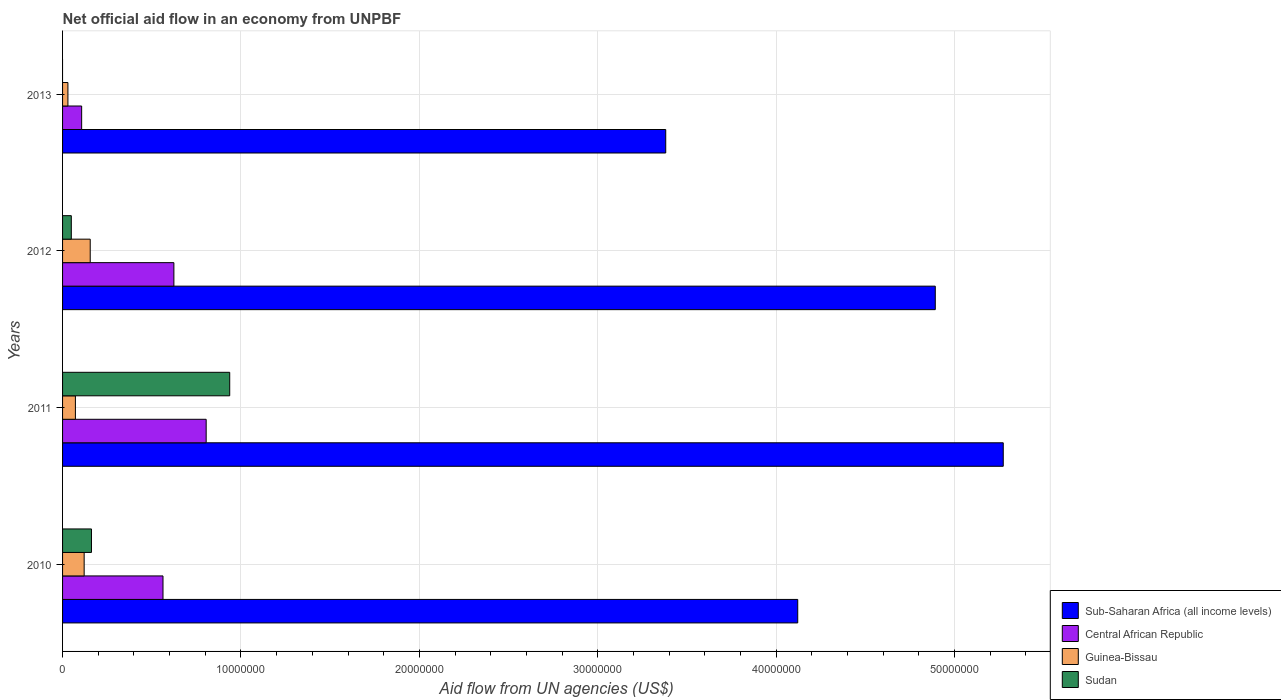How many different coloured bars are there?
Keep it short and to the point. 4. Are the number of bars on each tick of the Y-axis equal?
Provide a short and direct response. No. How many bars are there on the 1st tick from the top?
Offer a very short reply. 3. What is the label of the 4th group of bars from the top?
Offer a very short reply. 2010. In how many cases, is the number of bars for a given year not equal to the number of legend labels?
Provide a succinct answer. 1. What is the net official aid flow in Guinea-Bissau in 2013?
Provide a short and direct response. 3.00e+05. Across all years, what is the maximum net official aid flow in Central African Republic?
Provide a succinct answer. 8.05e+06. Across all years, what is the minimum net official aid flow in Sudan?
Give a very brief answer. 0. In which year was the net official aid flow in Sudan maximum?
Offer a very short reply. 2011. What is the total net official aid flow in Central African Republic in the graph?
Provide a short and direct response. 2.10e+07. What is the difference between the net official aid flow in Guinea-Bissau in 2011 and that in 2012?
Provide a succinct answer. -8.30e+05. What is the difference between the net official aid flow in Central African Republic in 2010 and the net official aid flow in Guinea-Bissau in 2012?
Provide a short and direct response. 4.08e+06. What is the average net official aid flow in Sudan per year?
Give a very brief answer. 2.87e+06. In the year 2011, what is the difference between the net official aid flow in Sub-Saharan Africa (all income levels) and net official aid flow in Sudan?
Your response must be concise. 4.34e+07. What is the ratio of the net official aid flow in Sub-Saharan Africa (all income levels) in 2010 to that in 2011?
Give a very brief answer. 0.78. Is the net official aid flow in Central African Republic in 2010 less than that in 2013?
Your response must be concise. No. Is the difference between the net official aid flow in Sub-Saharan Africa (all income levels) in 2010 and 2011 greater than the difference between the net official aid flow in Sudan in 2010 and 2011?
Give a very brief answer. No. What is the difference between the highest and the lowest net official aid flow in Central African Republic?
Make the answer very short. 6.98e+06. In how many years, is the net official aid flow in Sub-Saharan Africa (all income levels) greater than the average net official aid flow in Sub-Saharan Africa (all income levels) taken over all years?
Give a very brief answer. 2. Is the sum of the net official aid flow in Sub-Saharan Africa (all income levels) in 2011 and 2012 greater than the maximum net official aid flow in Guinea-Bissau across all years?
Offer a terse response. Yes. How many bars are there?
Ensure brevity in your answer.  15. Are all the bars in the graph horizontal?
Your answer should be very brief. Yes. How many years are there in the graph?
Provide a succinct answer. 4. What is the title of the graph?
Offer a very short reply. Net official aid flow in an economy from UNPBF. Does "Sint Maarten (Dutch part)" appear as one of the legend labels in the graph?
Keep it short and to the point. No. What is the label or title of the X-axis?
Keep it short and to the point. Aid flow from UN agencies (US$). What is the label or title of the Y-axis?
Your answer should be very brief. Years. What is the Aid flow from UN agencies (US$) in Sub-Saharan Africa (all income levels) in 2010?
Ensure brevity in your answer.  4.12e+07. What is the Aid flow from UN agencies (US$) of Central African Republic in 2010?
Your response must be concise. 5.63e+06. What is the Aid flow from UN agencies (US$) in Guinea-Bissau in 2010?
Your answer should be compact. 1.21e+06. What is the Aid flow from UN agencies (US$) of Sudan in 2010?
Your answer should be compact. 1.62e+06. What is the Aid flow from UN agencies (US$) of Sub-Saharan Africa (all income levels) in 2011?
Make the answer very short. 5.27e+07. What is the Aid flow from UN agencies (US$) in Central African Republic in 2011?
Your answer should be compact. 8.05e+06. What is the Aid flow from UN agencies (US$) of Guinea-Bissau in 2011?
Ensure brevity in your answer.  7.20e+05. What is the Aid flow from UN agencies (US$) of Sudan in 2011?
Keep it short and to the point. 9.37e+06. What is the Aid flow from UN agencies (US$) of Sub-Saharan Africa (all income levels) in 2012?
Your response must be concise. 4.89e+07. What is the Aid flow from UN agencies (US$) in Central African Republic in 2012?
Your response must be concise. 6.24e+06. What is the Aid flow from UN agencies (US$) of Guinea-Bissau in 2012?
Your answer should be compact. 1.55e+06. What is the Aid flow from UN agencies (US$) in Sub-Saharan Africa (all income levels) in 2013?
Offer a very short reply. 3.38e+07. What is the Aid flow from UN agencies (US$) in Central African Republic in 2013?
Provide a short and direct response. 1.07e+06. What is the Aid flow from UN agencies (US$) in Sudan in 2013?
Offer a very short reply. 0. Across all years, what is the maximum Aid flow from UN agencies (US$) of Sub-Saharan Africa (all income levels)?
Ensure brevity in your answer.  5.27e+07. Across all years, what is the maximum Aid flow from UN agencies (US$) of Central African Republic?
Give a very brief answer. 8.05e+06. Across all years, what is the maximum Aid flow from UN agencies (US$) in Guinea-Bissau?
Keep it short and to the point. 1.55e+06. Across all years, what is the maximum Aid flow from UN agencies (US$) in Sudan?
Provide a succinct answer. 9.37e+06. Across all years, what is the minimum Aid flow from UN agencies (US$) in Sub-Saharan Africa (all income levels)?
Keep it short and to the point. 3.38e+07. Across all years, what is the minimum Aid flow from UN agencies (US$) in Central African Republic?
Your answer should be very brief. 1.07e+06. Across all years, what is the minimum Aid flow from UN agencies (US$) in Guinea-Bissau?
Your answer should be compact. 3.00e+05. Across all years, what is the minimum Aid flow from UN agencies (US$) of Sudan?
Provide a succinct answer. 0. What is the total Aid flow from UN agencies (US$) of Sub-Saharan Africa (all income levels) in the graph?
Offer a very short reply. 1.77e+08. What is the total Aid flow from UN agencies (US$) of Central African Republic in the graph?
Your answer should be compact. 2.10e+07. What is the total Aid flow from UN agencies (US$) in Guinea-Bissau in the graph?
Make the answer very short. 3.78e+06. What is the total Aid flow from UN agencies (US$) in Sudan in the graph?
Keep it short and to the point. 1.15e+07. What is the difference between the Aid flow from UN agencies (US$) in Sub-Saharan Africa (all income levels) in 2010 and that in 2011?
Provide a succinct answer. -1.15e+07. What is the difference between the Aid flow from UN agencies (US$) in Central African Republic in 2010 and that in 2011?
Make the answer very short. -2.42e+06. What is the difference between the Aid flow from UN agencies (US$) of Sudan in 2010 and that in 2011?
Your response must be concise. -7.75e+06. What is the difference between the Aid flow from UN agencies (US$) in Sub-Saharan Africa (all income levels) in 2010 and that in 2012?
Provide a succinct answer. -7.71e+06. What is the difference between the Aid flow from UN agencies (US$) of Central African Republic in 2010 and that in 2012?
Your response must be concise. -6.10e+05. What is the difference between the Aid flow from UN agencies (US$) in Sudan in 2010 and that in 2012?
Provide a short and direct response. 1.13e+06. What is the difference between the Aid flow from UN agencies (US$) in Sub-Saharan Africa (all income levels) in 2010 and that in 2013?
Your response must be concise. 7.40e+06. What is the difference between the Aid flow from UN agencies (US$) of Central African Republic in 2010 and that in 2013?
Keep it short and to the point. 4.56e+06. What is the difference between the Aid flow from UN agencies (US$) in Guinea-Bissau in 2010 and that in 2013?
Offer a very short reply. 9.10e+05. What is the difference between the Aid flow from UN agencies (US$) of Sub-Saharan Africa (all income levels) in 2011 and that in 2012?
Ensure brevity in your answer.  3.81e+06. What is the difference between the Aid flow from UN agencies (US$) of Central African Republic in 2011 and that in 2012?
Provide a succinct answer. 1.81e+06. What is the difference between the Aid flow from UN agencies (US$) of Guinea-Bissau in 2011 and that in 2012?
Offer a terse response. -8.30e+05. What is the difference between the Aid flow from UN agencies (US$) of Sudan in 2011 and that in 2012?
Give a very brief answer. 8.88e+06. What is the difference between the Aid flow from UN agencies (US$) in Sub-Saharan Africa (all income levels) in 2011 and that in 2013?
Your answer should be compact. 1.89e+07. What is the difference between the Aid flow from UN agencies (US$) in Central African Republic in 2011 and that in 2013?
Your answer should be compact. 6.98e+06. What is the difference between the Aid flow from UN agencies (US$) in Sub-Saharan Africa (all income levels) in 2012 and that in 2013?
Offer a terse response. 1.51e+07. What is the difference between the Aid flow from UN agencies (US$) of Central African Republic in 2012 and that in 2013?
Provide a succinct answer. 5.17e+06. What is the difference between the Aid flow from UN agencies (US$) in Guinea-Bissau in 2012 and that in 2013?
Offer a very short reply. 1.25e+06. What is the difference between the Aid flow from UN agencies (US$) of Sub-Saharan Africa (all income levels) in 2010 and the Aid flow from UN agencies (US$) of Central African Republic in 2011?
Offer a terse response. 3.32e+07. What is the difference between the Aid flow from UN agencies (US$) of Sub-Saharan Africa (all income levels) in 2010 and the Aid flow from UN agencies (US$) of Guinea-Bissau in 2011?
Provide a short and direct response. 4.05e+07. What is the difference between the Aid flow from UN agencies (US$) in Sub-Saharan Africa (all income levels) in 2010 and the Aid flow from UN agencies (US$) in Sudan in 2011?
Provide a short and direct response. 3.18e+07. What is the difference between the Aid flow from UN agencies (US$) in Central African Republic in 2010 and the Aid flow from UN agencies (US$) in Guinea-Bissau in 2011?
Offer a very short reply. 4.91e+06. What is the difference between the Aid flow from UN agencies (US$) in Central African Republic in 2010 and the Aid flow from UN agencies (US$) in Sudan in 2011?
Offer a terse response. -3.74e+06. What is the difference between the Aid flow from UN agencies (US$) in Guinea-Bissau in 2010 and the Aid flow from UN agencies (US$) in Sudan in 2011?
Your response must be concise. -8.16e+06. What is the difference between the Aid flow from UN agencies (US$) of Sub-Saharan Africa (all income levels) in 2010 and the Aid flow from UN agencies (US$) of Central African Republic in 2012?
Keep it short and to the point. 3.50e+07. What is the difference between the Aid flow from UN agencies (US$) of Sub-Saharan Africa (all income levels) in 2010 and the Aid flow from UN agencies (US$) of Guinea-Bissau in 2012?
Offer a very short reply. 3.97e+07. What is the difference between the Aid flow from UN agencies (US$) of Sub-Saharan Africa (all income levels) in 2010 and the Aid flow from UN agencies (US$) of Sudan in 2012?
Offer a terse response. 4.07e+07. What is the difference between the Aid flow from UN agencies (US$) in Central African Republic in 2010 and the Aid flow from UN agencies (US$) in Guinea-Bissau in 2012?
Give a very brief answer. 4.08e+06. What is the difference between the Aid flow from UN agencies (US$) in Central African Republic in 2010 and the Aid flow from UN agencies (US$) in Sudan in 2012?
Keep it short and to the point. 5.14e+06. What is the difference between the Aid flow from UN agencies (US$) in Guinea-Bissau in 2010 and the Aid flow from UN agencies (US$) in Sudan in 2012?
Make the answer very short. 7.20e+05. What is the difference between the Aid flow from UN agencies (US$) in Sub-Saharan Africa (all income levels) in 2010 and the Aid flow from UN agencies (US$) in Central African Republic in 2013?
Make the answer very short. 4.01e+07. What is the difference between the Aid flow from UN agencies (US$) of Sub-Saharan Africa (all income levels) in 2010 and the Aid flow from UN agencies (US$) of Guinea-Bissau in 2013?
Offer a terse response. 4.09e+07. What is the difference between the Aid flow from UN agencies (US$) in Central African Republic in 2010 and the Aid flow from UN agencies (US$) in Guinea-Bissau in 2013?
Your answer should be compact. 5.33e+06. What is the difference between the Aid flow from UN agencies (US$) of Sub-Saharan Africa (all income levels) in 2011 and the Aid flow from UN agencies (US$) of Central African Republic in 2012?
Offer a very short reply. 4.65e+07. What is the difference between the Aid flow from UN agencies (US$) in Sub-Saharan Africa (all income levels) in 2011 and the Aid flow from UN agencies (US$) in Guinea-Bissau in 2012?
Make the answer very short. 5.12e+07. What is the difference between the Aid flow from UN agencies (US$) in Sub-Saharan Africa (all income levels) in 2011 and the Aid flow from UN agencies (US$) in Sudan in 2012?
Give a very brief answer. 5.22e+07. What is the difference between the Aid flow from UN agencies (US$) of Central African Republic in 2011 and the Aid flow from UN agencies (US$) of Guinea-Bissau in 2012?
Give a very brief answer. 6.50e+06. What is the difference between the Aid flow from UN agencies (US$) of Central African Republic in 2011 and the Aid flow from UN agencies (US$) of Sudan in 2012?
Provide a succinct answer. 7.56e+06. What is the difference between the Aid flow from UN agencies (US$) in Sub-Saharan Africa (all income levels) in 2011 and the Aid flow from UN agencies (US$) in Central African Republic in 2013?
Your answer should be compact. 5.17e+07. What is the difference between the Aid flow from UN agencies (US$) in Sub-Saharan Africa (all income levels) in 2011 and the Aid flow from UN agencies (US$) in Guinea-Bissau in 2013?
Offer a very short reply. 5.24e+07. What is the difference between the Aid flow from UN agencies (US$) of Central African Republic in 2011 and the Aid flow from UN agencies (US$) of Guinea-Bissau in 2013?
Provide a succinct answer. 7.75e+06. What is the difference between the Aid flow from UN agencies (US$) of Sub-Saharan Africa (all income levels) in 2012 and the Aid flow from UN agencies (US$) of Central African Republic in 2013?
Ensure brevity in your answer.  4.78e+07. What is the difference between the Aid flow from UN agencies (US$) of Sub-Saharan Africa (all income levels) in 2012 and the Aid flow from UN agencies (US$) of Guinea-Bissau in 2013?
Ensure brevity in your answer.  4.86e+07. What is the difference between the Aid flow from UN agencies (US$) of Central African Republic in 2012 and the Aid flow from UN agencies (US$) of Guinea-Bissau in 2013?
Keep it short and to the point. 5.94e+06. What is the average Aid flow from UN agencies (US$) of Sub-Saharan Africa (all income levels) per year?
Your response must be concise. 4.42e+07. What is the average Aid flow from UN agencies (US$) in Central African Republic per year?
Make the answer very short. 5.25e+06. What is the average Aid flow from UN agencies (US$) in Guinea-Bissau per year?
Provide a short and direct response. 9.45e+05. What is the average Aid flow from UN agencies (US$) in Sudan per year?
Your response must be concise. 2.87e+06. In the year 2010, what is the difference between the Aid flow from UN agencies (US$) of Sub-Saharan Africa (all income levels) and Aid flow from UN agencies (US$) of Central African Republic?
Provide a short and direct response. 3.56e+07. In the year 2010, what is the difference between the Aid flow from UN agencies (US$) in Sub-Saharan Africa (all income levels) and Aid flow from UN agencies (US$) in Guinea-Bissau?
Keep it short and to the point. 4.00e+07. In the year 2010, what is the difference between the Aid flow from UN agencies (US$) of Sub-Saharan Africa (all income levels) and Aid flow from UN agencies (US$) of Sudan?
Give a very brief answer. 3.96e+07. In the year 2010, what is the difference between the Aid flow from UN agencies (US$) in Central African Republic and Aid flow from UN agencies (US$) in Guinea-Bissau?
Provide a short and direct response. 4.42e+06. In the year 2010, what is the difference between the Aid flow from UN agencies (US$) of Central African Republic and Aid flow from UN agencies (US$) of Sudan?
Offer a very short reply. 4.01e+06. In the year 2010, what is the difference between the Aid flow from UN agencies (US$) of Guinea-Bissau and Aid flow from UN agencies (US$) of Sudan?
Offer a terse response. -4.10e+05. In the year 2011, what is the difference between the Aid flow from UN agencies (US$) of Sub-Saharan Africa (all income levels) and Aid flow from UN agencies (US$) of Central African Republic?
Provide a short and direct response. 4.47e+07. In the year 2011, what is the difference between the Aid flow from UN agencies (US$) of Sub-Saharan Africa (all income levels) and Aid flow from UN agencies (US$) of Guinea-Bissau?
Give a very brief answer. 5.20e+07. In the year 2011, what is the difference between the Aid flow from UN agencies (US$) in Sub-Saharan Africa (all income levels) and Aid flow from UN agencies (US$) in Sudan?
Your answer should be compact. 4.34e+07. In the year 2011, what is the difference between the Aid flow from UN agencies (US$) of Central African Republic and Aid flow from UN agencies (US$) of Guinea-Bissau?
Your answer should be compact. 7.33e+06. In the year 2011, what is the difference between the Aid flow from UN agencies (US$) of Central African Republic and Aid flow from UN agencies (US$) of Sudan?
Keep it short and to the point. -1.32e+06. In the year 2011, what is the difference between the Aid flow from UN agencies (US$) in Guinea-Bissau and Aid flow from UN agencies (US$) in Sudan?
Make the answer very short. -8.65e+06. In the year 2012, what is the difference between the Aid flow from UN agencies (US$) of Sub-Saharan Africa (all income levels) and Aid flow from UN agencies (US$) of Central African Republic?
Ensure brevity in your answer.  4.27e+07. In the year 2012, what is the difference between the Aid flow from UN agencies (US$) of Sub-Saharan Africa (all income levels) and Aid flow from UN agencies (US$) of Guinea-Bissau?
Make the answer very short. 4.74e+07. In the year 2012, what is the difference between the Aid flow from UN agencies (US$) of Sub-Saharan Africa (all income levels) and Aid flow from UN agencies (US$) of Sudan?
Provide a succinct answer. 4.84e+07. In the year 2012, what is the difference between the Aid flow from UN agencies (US$) of Central African Republic and Aid flow from UN agencies (US$) of Guinea-Bissau?
Offer a terse response. 4.69e+06. In the year 2012, what is the difference between the Aid flow from UN agencies (US$) in Central African Republic and Aid flow from UN agencies (US$) in Sudan?
Make the answer very short. 5.75e+06. In the year 2012, what is the difference between the Aid flow from UN agencies (US$) of Guinea-Bissau and Aid flow from UN agencies (US$) of Sudan?
Give a very brief answer. 1.06e+06. In the year 2013, what is the difference between the Aid flow from UN agencies (US$) of Sub-Saharan Africa (all income levels) and Aid flow from UN agencies (US$) of Central African Republic?
Provide a short and direct response. 3.27e+07. In the year 2013, what is the difference between the Aid flow from UN agencies (US$) of Sub-Saharan Africa (all income levels) and Aid flow from UN agencies (US$) of Guinea-Bissau?
Give a very brief answer. 3.35e+07. In the year 2013, what is the difference between the Aid flow from UN agencies (US$) of Central African Republic and Aid flow from UN agencies (US$) of Guinea-Bissau?
Your answer should be compact. 7.70e+05. What is the ratio of the Aid flow from UN agencies (US$) of Sub-Saharan Africa (all income levels) in 2010 to that in 2011?
Give a very brief answer. 0.78. What is the ratio of the Aid flow from UN agencies (US$) of Central African Republic in 2010 to that in 2011?
Your response must be concise. 0.7. What is the ratio of the Aid flow from UN agencies (US$) in Guinea-Bissau in 2010 to that in 2011?
Ensure brevity in your answer.  1.68. What is the ratio of the Aid flow from UN agencies (US$) in Sudan in 2010 to that in 2011?
Ensure brevity in your answer.  0.17. What is the ratio of the Aid flow from UN agencies (US$) of Sub-Saharan Africa (all income levels) in 2010 to that in 2012?
Your answer should be compact. 0.84. What is the ratio of the Aid flow from UN agencies (US$) in Central African Republic in 2010 to that in 2012?
Offer a terse response. 0.9. What is the ratio of the Aid flow from UN agencies (US$) of Guinea-Bissau in 2010 to that in 2012?
Offer a terse response. 0.78. What is the ratio of the Aid flow from UN agencies (US$) in Sudan in 2010 to that in 2012?
Your answer should be compact. 3.31. What is the ratio of the Aid flow from UN agencies (US$) in Sub-Saharan Africa (all income levels) in 2010 to that in 2013?
Ensure brevity in your answer.  1.22. What is the ratio of the Aid flow from UN agencies (US$) in Central African Republic in 2010 to that in 2013?
Ensure brevity in your answer.  5.26. What is the ratio of the Aid flow from UN agencies (US$) in Guinea-Bissau in 2010 to that in 2013?
Offer a terse response. 4.03. What is the ratio of the Aid flow from UN agencies (US$) of Sub-Saharan Africa (all income levels) in 2011 to that in 2012?
Offer a very short reply. 1.08. What is the ratio of the Aid flow from UN agencies (US$) of Central African Republic in 2011 to that in 2012?
Your answer should be compact. 1.29. What is the ratio of the Aid flow from UN agencies (US$) in Guinea-Bissau in 2011 to that in 2012?
Ensure brevity in your answer.  0.46. What is the ratio of the Aid flow from UN agencies (US$) of Sudan in 2011 to that in 2012?
Provide a succinct answer. 19.12. What is the ratio of the Aid flow from UN agencies (US$) of Sub-Saharan Africa (all income levels) in 2011 to that in 2013?
Provide a succinct answer. 1.56. What is the ratio of the Aid flow from UN agencies (US$) of Central African Republic in 2011 to that in 2013?
Provide a short and direct response. 7.52. What is the ratio of the Aid flow from UN agencies (US$) in Sub-Saharan Africa (all income levels) in 2012 to that in 2013?
Ensure brevity in your answer.  1.45. What is the ratio of the Aid flow from UN agencies (US$) in Central African Republic in 2012 to that in 2013?
Provide a succinct answer. 5.83. What is the ratio of the Aid flow from UN agencies (US$) in Guinea-Bissau in 2012 to that in 2013?
Make the answer very short. 5.17. What is the difference between the highest and the second highest Aid flow from UN agencies (US$) of Sub-Saharan Africa (all income levels)?
Offer a terse response. 3.81e+06. What is the difference between the highest and the second highest Aid flow from UN agencies (US$) of Central African Republic?
Your answer should be very brief. 1.81e+06. What is the difference between the highest and the second highest Aid flow from UN agencies (US$) of Guinea-Bissau?
Your response must be concise. 3.40e+05. What is the difference between the highest and the second highest Aid flow from UN agencies (US$) of Sudan?
Your answer should be compact. 7.75e+06. What is the difference between the highest and the lowest Aid flow from UN agencies (US$) in Sub-Saharan Africa (all income levels)?
Give a very brief answer. 1.89e+07. What is the difference between the highest and the lowest Aid flow from UN agencies (US$) of Central African Republic?
Your answer should be compact. 6.98e+06. What is the difference between the highest and the lowest Aid flow from UN agencies (US$) of Guinea-Bissau?
Your response must be concise. 1.25e+06. What is the difference between the highest and the lowest Aid flow from UN agencies (US$) of Sudan?
Ensure brevity in your answer.  9.37e+06. 